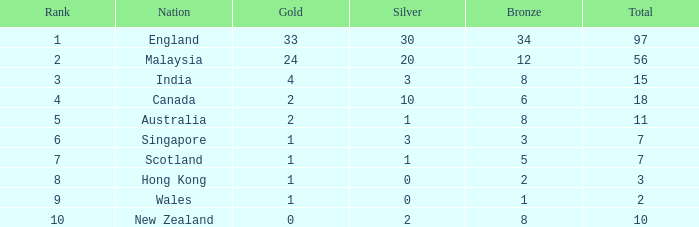What is the most gold medals a team with less than 2 silvers, more than 7 total medals, and less than 8 bronze medals has? None. Could you parse the entire table as a dict? {'header': ['Rank', 'Nation', 'Gold', 'Silver', 'Bronze', 'Total'], 'rows': [['1', 'England', '33', '30', '34', '97'], ['2', 'Malaysia', '24', '20', '12', '56'], ['3', 'India', '4', '3', '8', '15'], ['4', 'Canada', '2', '10', '6', '18'], ['5', 'Australia', '2', '1', '8', '11'], ['6', 'Singapore', '1', '3', '3', '7'], ['7', 'Scotland', '1', '1', '5', '7'], ['8', 'Hong Kong', '1', '0', '2', '3'], ['9', 'Wales', '1', '0', '1', '2'], ['10', 'New Zealand', '0', '2', '8', '10']]} 